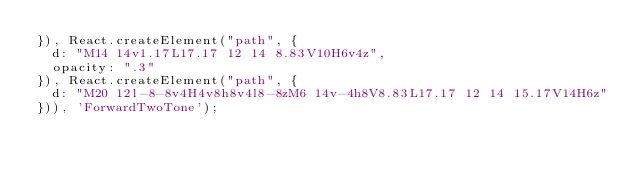<code> <loc_0><loc_0><loc_500><loc_500><_JavaScript_>}), React.createElement("path", {
  d: "M14 14v1.17L17.17 12 14 8.83V10H6v4z",
  opacity: ".3"
}), React.createElement("path", {
  d: "M20 12l-8-8v4H4v8h8v4l8-8zM6 14v-4h8V8.83L17.17 12 14 15.17V14H6z"
})), 'ForwardTwoTone');</code> 